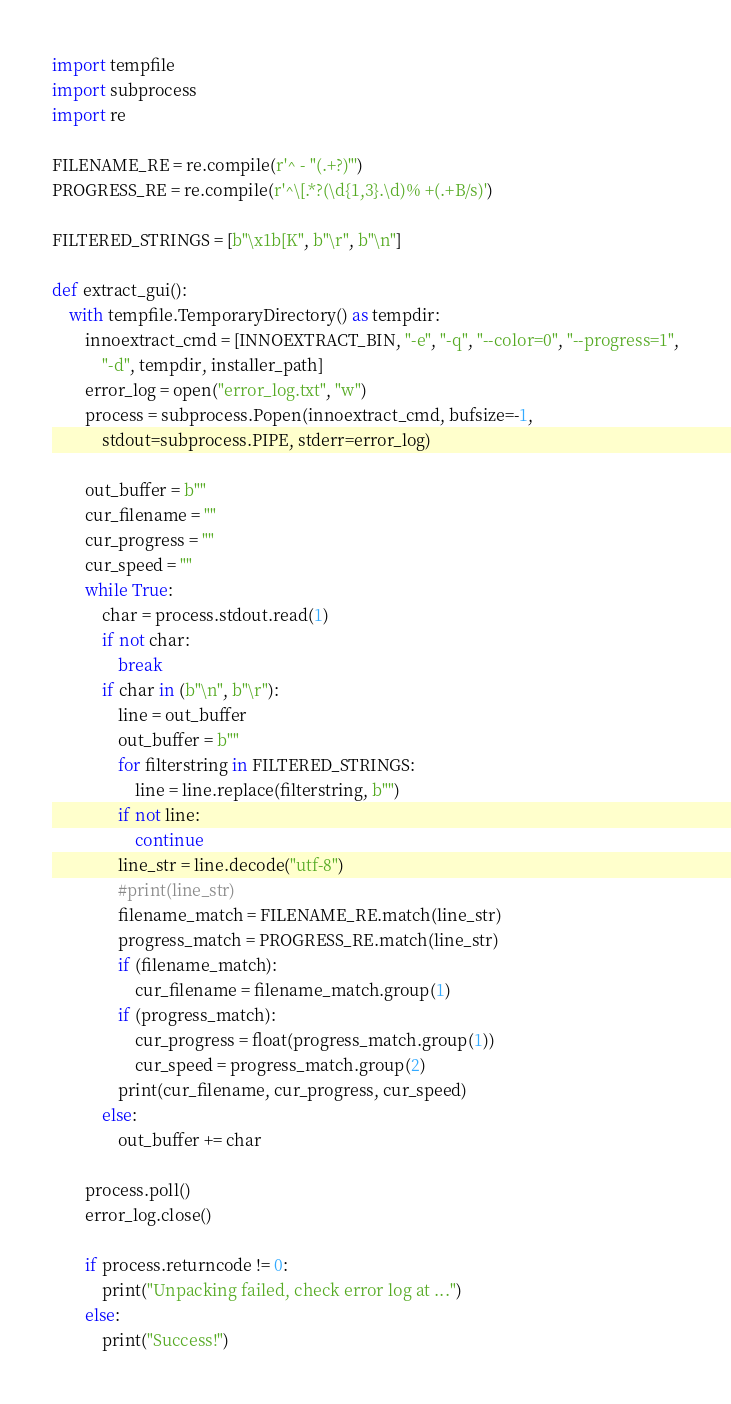Convert code to text. <code><loc_0><loc_0><loc_500><loc_500><_Python_>import tempfile
import subprocess
import re

FILENAME_RE = re.compile(r'^ - "(.+?)"')
PROGRESS_RE = re.compile(r'^\[.*?(\d{1,3}.\d)% +(.+B/s)')

FILTERED_STRINGS = [b"\x1b[K", b"\r", b"\n"]

def extract_gui():
    with tempfile.TemporaryDirectory() as tempdir:
        innoextract_cmd = [INNOEXTRACT_BIN, "-e", "-q", "--color=0", "--progress=1",
            "-d", tempdir, installer_path]
        error_log = open("error_log.txt", "w")
        process = subprocess.Popen(innoextract_cmd, bufsize=-1, 
            stdout=subprocess.PIPE, stderr=error_log)
        
        out_buffer = b""
        cur_filename = ""
        cur_progress = ""
        cur_speed = ""
        while True:
            char = process.stdout.read(1)
            if not char:
                break
            if char in (b"\n", b"\r"):
                line = out_buffer
                out_buffer = b""
                for filterstring in FILTERED_STRINGS:
                    line = line.replace(filterstring, b"")
                if not line:
                    continue
                line_str = line.decode("utf-8")
                #print(line_str)
                filename_match = FILENAME_RE.match(line_str)
                progress_match = PROGRESS_RE.match(line_str)
                if (filename_match):
                    cur_filename = filename_match.group(1)
                if (progress_match):
                    cur_progress = float(progress_match.group(1))
                    cur_speed = progress_match.group(2)
                print(cur_filename, cur_progress, cur_speed)
            else:
                out_buffer += char

        process.poll()
        error_log.close()

        if process.returncode != 0:
            print("Unpacking failed, check error log at ...")
        else:
            print("Success!")
</code> 